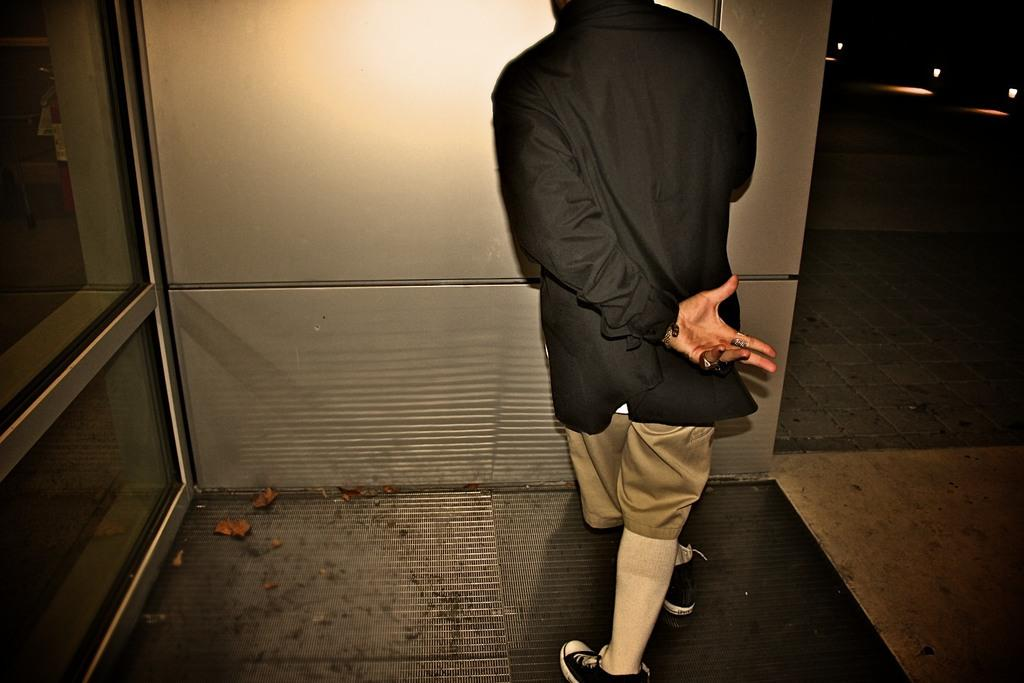What can be seen in the image? There is a person in the image. What is the person wearing? The person is wearing a black shirt. Where is the person standing? The person is standing on the floor. What is present on the right side of the image? There are three lights on the right side of the image. What is in front of the person? There is a wall in front of the person. What type of yam is the person holding in the image? There is no yam present in the image; the person is not holding anything. 